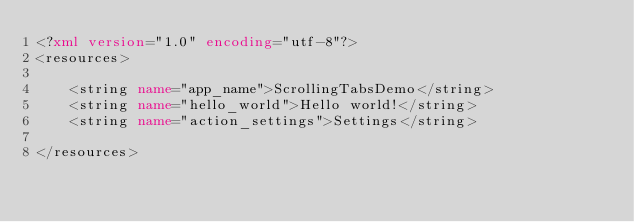<code> <loc_0><loc_0><loc_500><loc_500><_XML_><?xml version="1.0" encoding="utf-8"?>
<resources>

    <string name="app_name">ScrollingTabsDemo</string>
    <string name="hello_world">Hello world!</string>
    <string name="action_settings">Settings</string>

</resources>
</code> 